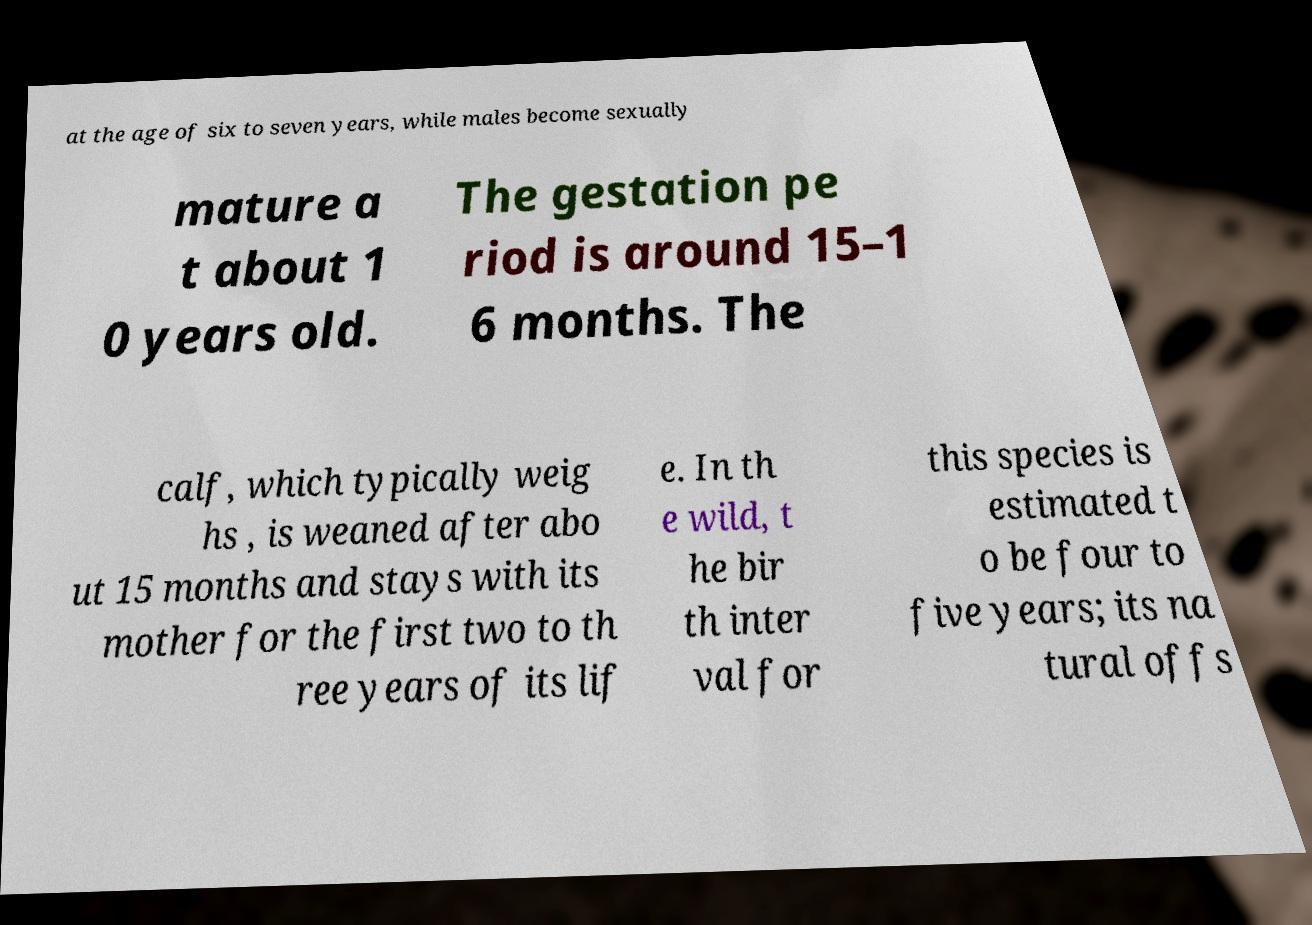Can you read and provide the text displayed in the image?This photo seems to have some interesting text. Can you extract and type it out for me? at the age of six to seven years, while males become sexually mature a t about 1 0 years old. The gestation pe riod is around 15–1 6 months. The calf, which typically weig hs , is weaned after abo ut 15 months and stays with its mother for the first two to th ree years of its lif e. In th e wild, t he bir th inter val for this species is estimated t o be four to five years; its na tural offs 